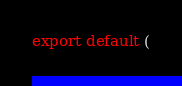Convert code to text. <code><loc_0><loc_0><loc_500><loc_500><_TypeScript_>export default (</code> 